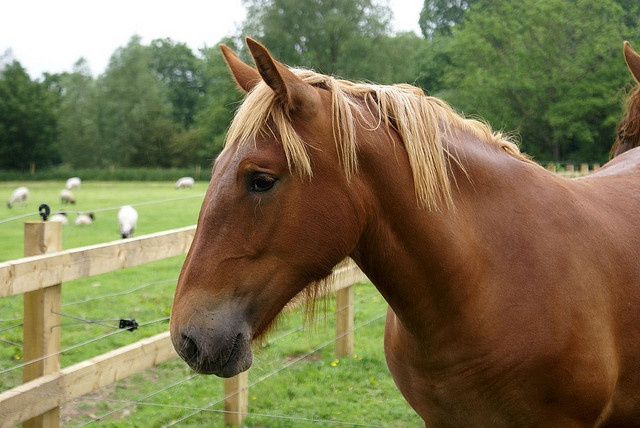Describe the objects in this image and their specific colors. I can see horse in white, maroon, black, and gray tones, horse in white, olive, maroon, black, and gray tones, sheep in white, ivory, lightgreen, darkgray, and khaki tones, sheep in white, ivory, tan, beige, and olive tones, and sheep in white, lightgray, tan, darkgray, and khaki tones in this image. 